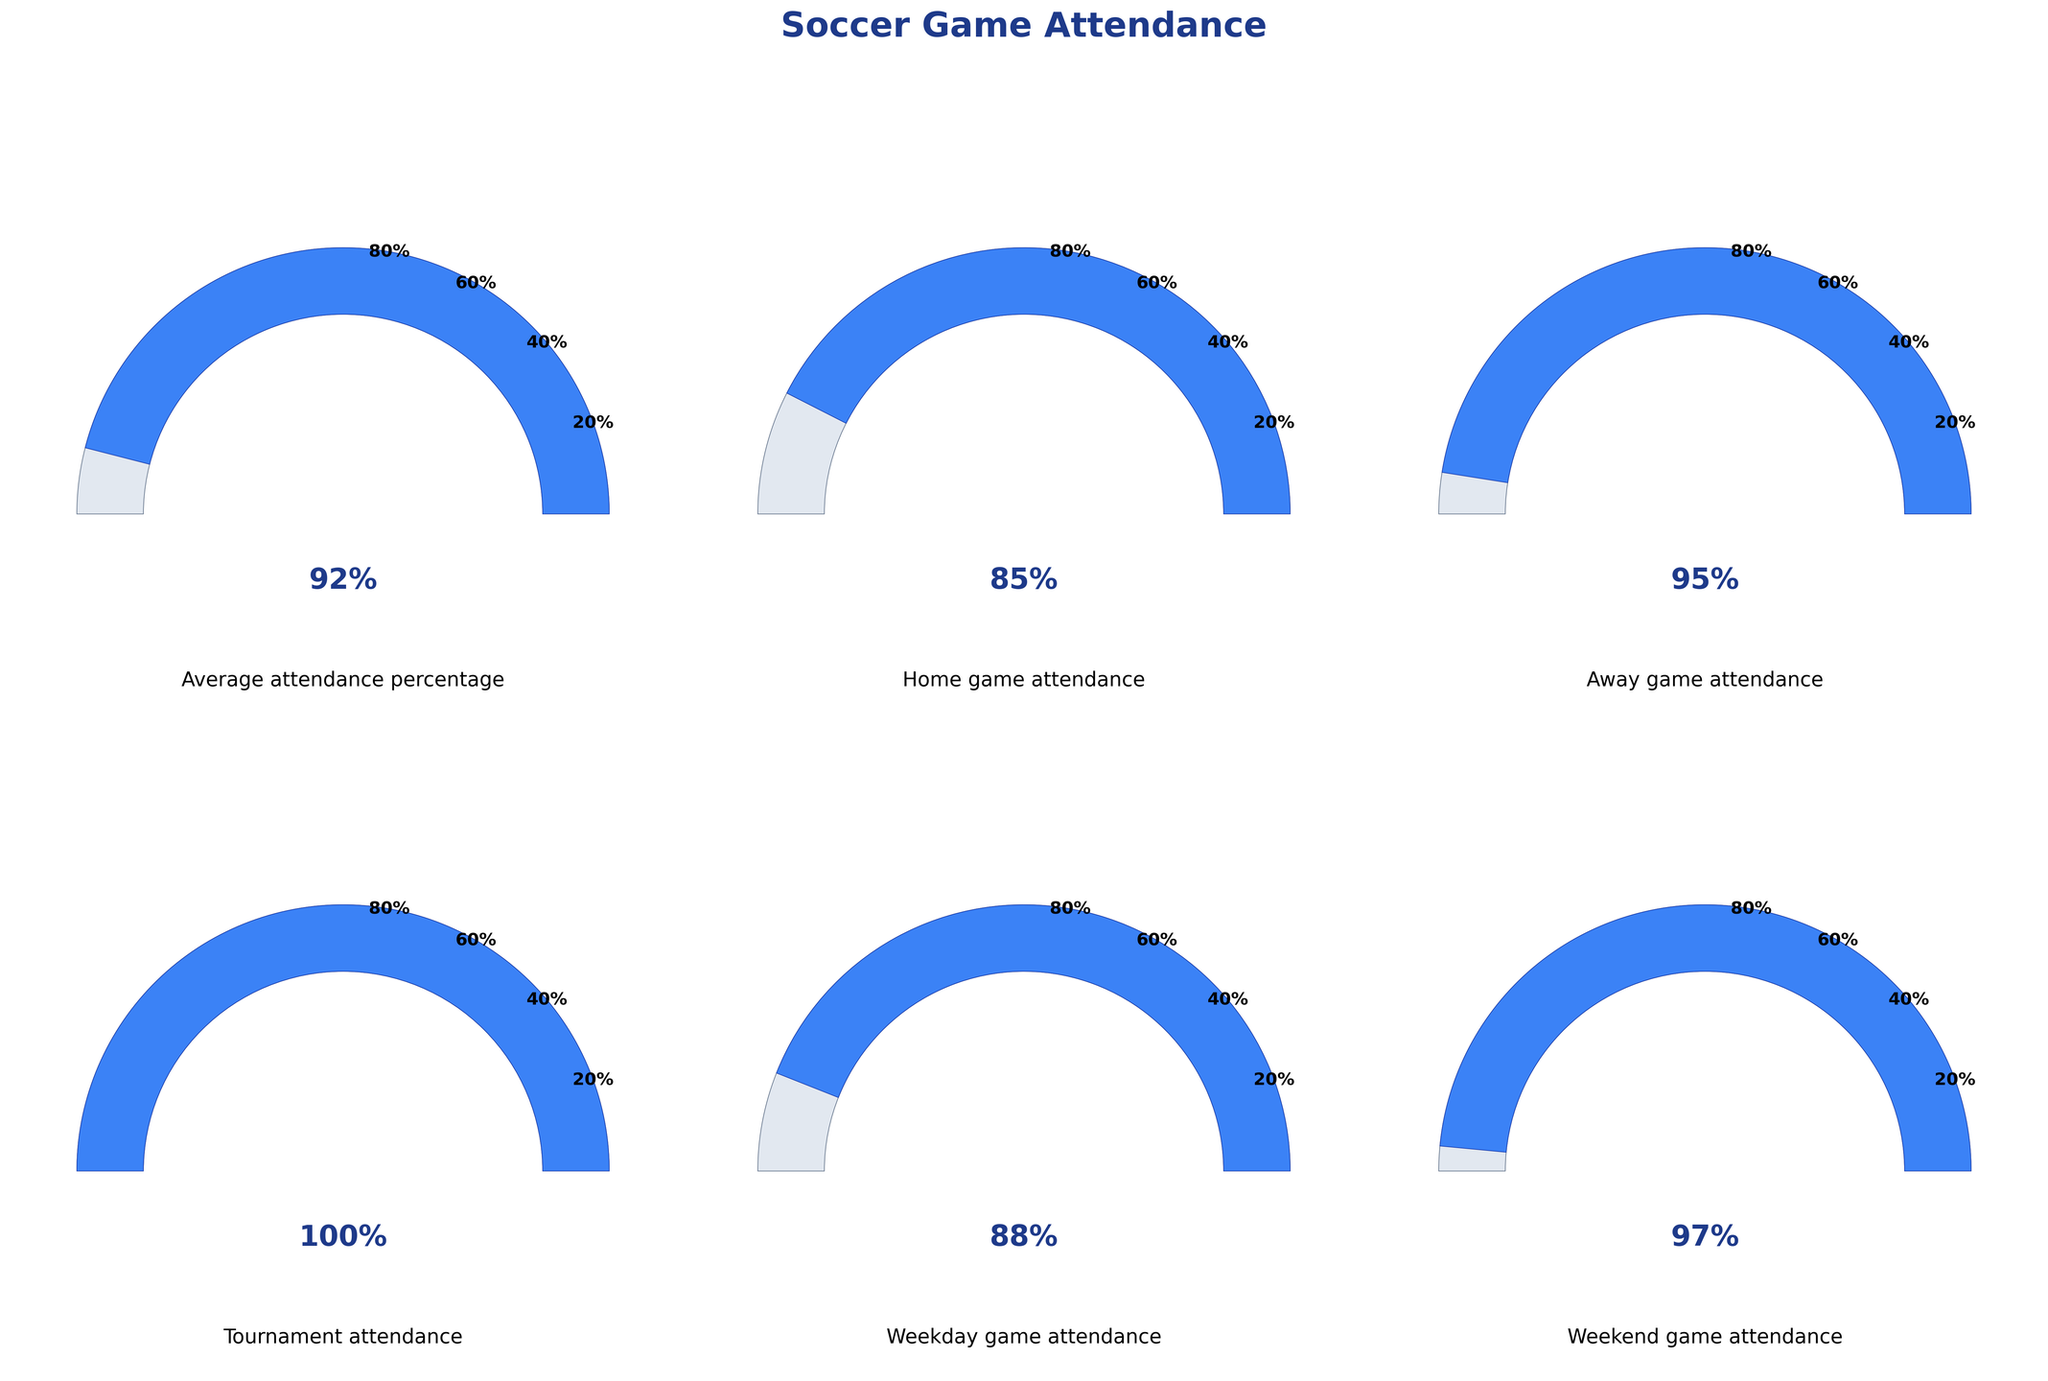What is the average attendance percentage at your grandchild's soccer games? The gauge for "Average attendance percentage" shows 92%, which is indicated by the needle position and labeled below the semi-circle.
Answer: 92% Which type of game has the highest attendance percentage? The "Tournament attendance" gauge shows 100%, which is higher than all other gauges.
Answer: Tournament games What is the difference in attendance percentages between home games and away games? The "Home game attendance" is 85% and the "Away game attendance" is 95%. Subtracting these gives 95% - 85% = 10%.
Answer: 10% Among weekday and weekend games, which one has a higher attendance percentage? The "Weekend game attendance" shows 97%, which is higher than the "Weekday game attendance" of 88%.
Answer: Weekend games What is the overall trend in attendance at various types of events? By looking at all gauges, we see high attendance across all categories, especially during tournament and weekend games, with percentages all above 85%.
Answer: High attendance across all types If the average attendance percentage is 92%, what is the combined percentage for home and away games? Home and away percentages are 85% and 95%. Adding them gives 85% + 95% = 180%.
Answer: 180% How does the weekend game attendance compare to the overall average attendance? The "Weekend game attendance" is 97%, which is higher than the "Average attendance percentage" of 92%.
Answer: Higher What percentage of attendance is below 90%? The "Home game attendance" (85%) and "Weekday game attendance" (88%) are below 90%.
Answer: Two categories Which gauge shows the lowest attendance percentage? The "Home game attendance" gauge shows the lowest percentage at 85%.
Answer: Home games If the tournament attendance is 100%, what percentage are all other categories below or equal to the tournament attendance? All other categories (average, home, away, weekday, and weekend) are at or below 100%.
Answer: 5 categories 